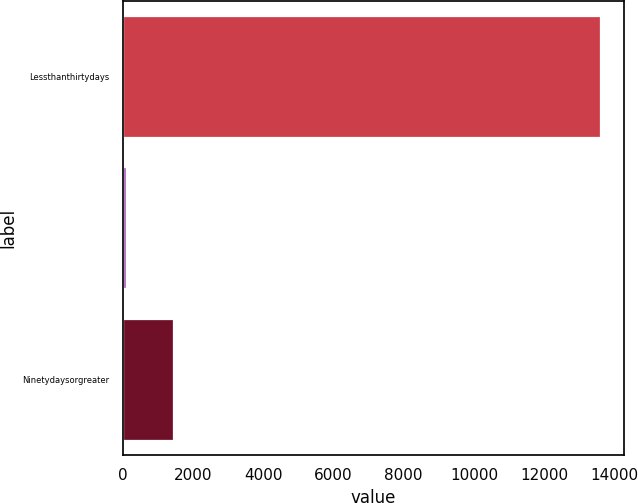<chart> <loc_0><loc_0><loc_500><loc_500><bar_chart><fcel>Lessthanthirtydays<fcel>Unnamed: 1<fcel>Ninetydaysorgreater<nl><fcel>13605<fcel>92<fcel>1443.3<nl></chart> 